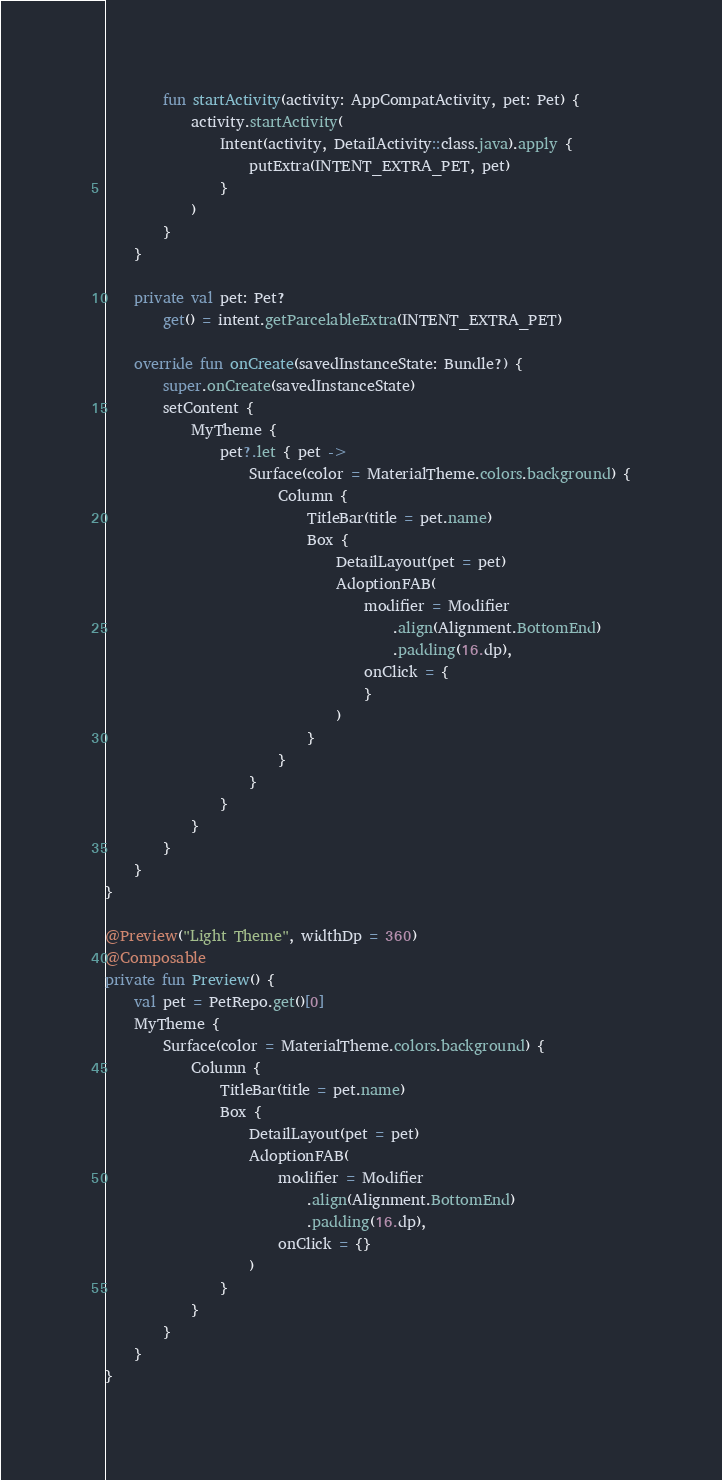Convert code to text. <code><loc_0><loc_0><loc_500><loc_500><_Kotlin_>        fun startActivity(activity: AppCompatActivity, pet: Pet) {
            activity.startActivity(
                Intent(activity, DetailActivity::class.java).apply {
                    putExtra(INTENT_EXTRA_PET, pet)
                }
            )
        }
    }

    private val pet: Pet?
        get() = intent.getParcelableExtra(INTENT_EXTRA_PET)

    override fun onCreate(savedInstanceState: Bundle?) {
        super.onCreate(savedInstanceState)
        setContent {
            MyTheme {
                pet?.let { pet ->
                    Surface(color = MaterialTheme.colors.background) {
                        Column {
                            TitleBar(title = pet.name)
                            Box {
                                DetailLayout(pet = pet)
                                AdoptionFAB(
                                    modifier = Modifier
                                        .align(Alignment.BottomEnd)
                                        .padding(16.dp),
                                    onClick = {
                                    }
                                )
                            }
                        }
                    }
                }
            }
        }
    }
}

@Preview("Light Theme", widthDp = 360)
@Composable
private fun Preview() {
    val pet = PetRepo.get()[0]
    MyTheme {
        Surface(color = MaterialTheme.colors.background) {
            Column {
                TitleBar(title = pet.name)
                Box {
                    DetailLayout(pet = pet)
                    AdoptionFAB(
                        modifier = Modifier
                            .align(Alignment.BottomEnd)
                            .padding(16.dp),
                        onClick = {}
                    )
                }
            }
        }
    }
}
</code> 